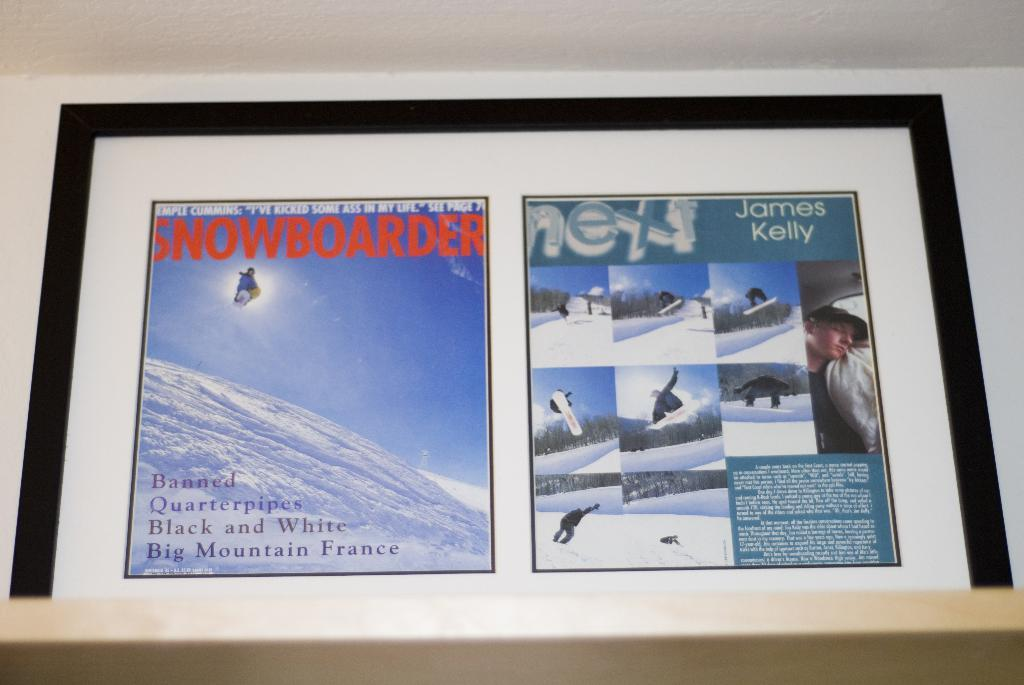<image>
Describe the image concisely. a frame that has snowboarder written on it 